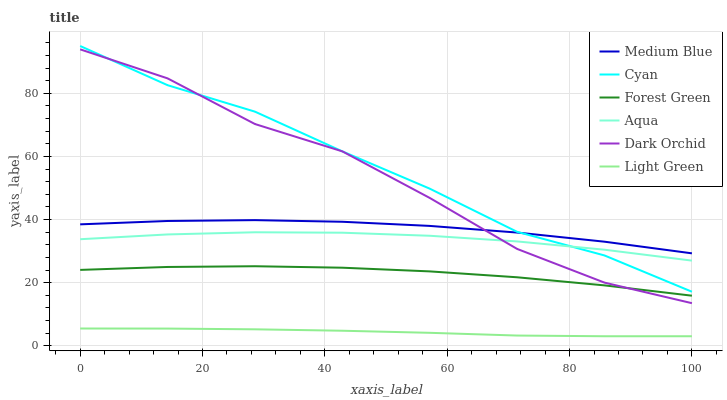Does Light Green have the minimum area under the curve?
Answer yes or no. Yes. Does Cyan have the maximum area under the curve?
Answer yes or no. Yes. Does Aqua have the minimum area under the curve?
Answer yes or no. No. Does Aqua have the maximum area under the curve?
Answer yes or no. No. Is Light Green the smoothest?
Answer yes or no. Yes. Is Dark Orchid the roughest?
Answer yes or no. Yes. Is Aqua the smoothest?
Answer yes or no. No. Is Aqua the roughest?
Answer yes or no. No. Does Light Green have the lowest value?
Answer yes or no. Yes. Does Aqua have the lowest value?
Answer yes or no. No. Does Cyan have the highest value?
Answer yes or no. Yes. Does Aqua have the highest value?
Answer yes or no. No. Is Light Green less than Cyan?
Answer yes or no. Yes. Is Medium Blue greater than Forest Green?
Answer yes or no. Yes. Does Cyan intersect Aqua?
Answer yes or no. Yes. Is Cyan less than Aqua?
Answer yes or no. No. Is Cyan greater than Aqua?
Answer yes or no. No. Does Light Green intersect Cyan?
Answer yes or no. No. 